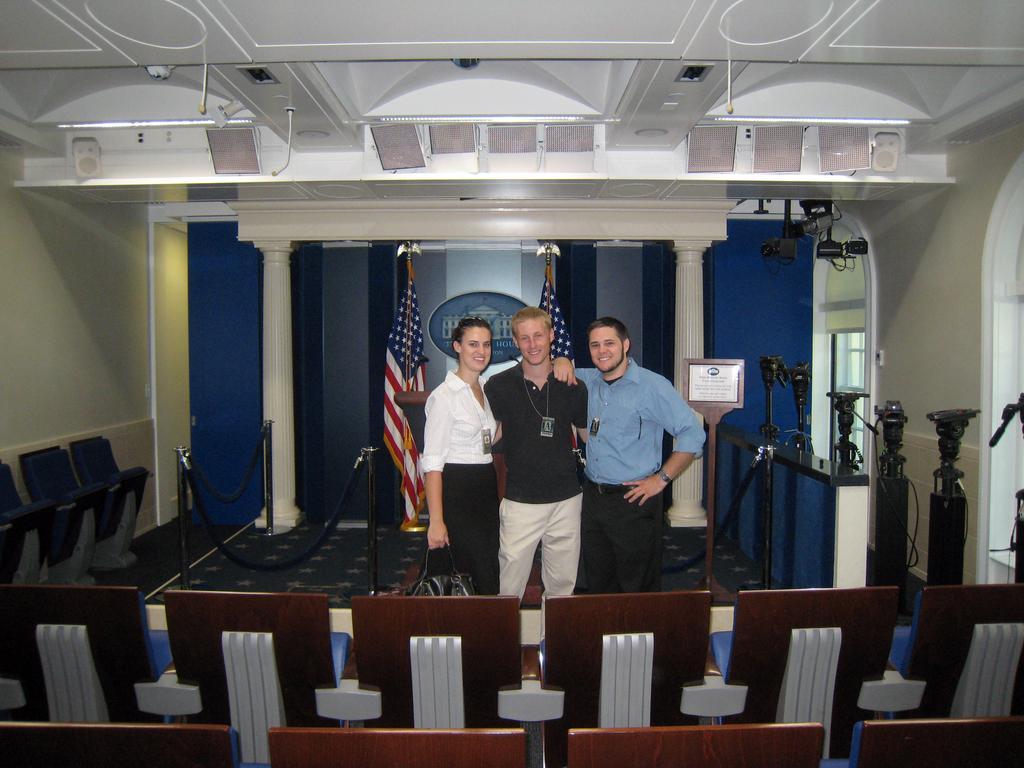Please provide a concise description of this image. This picture is clicked inside the hall. In the foreground we can see the chairs. In the center we can see the cameras, metal rods, group of persons standing on the ground and we can see a bag, cameras, pillars, flags and the wall. At the top we can see the roof and the ceiling lights. 